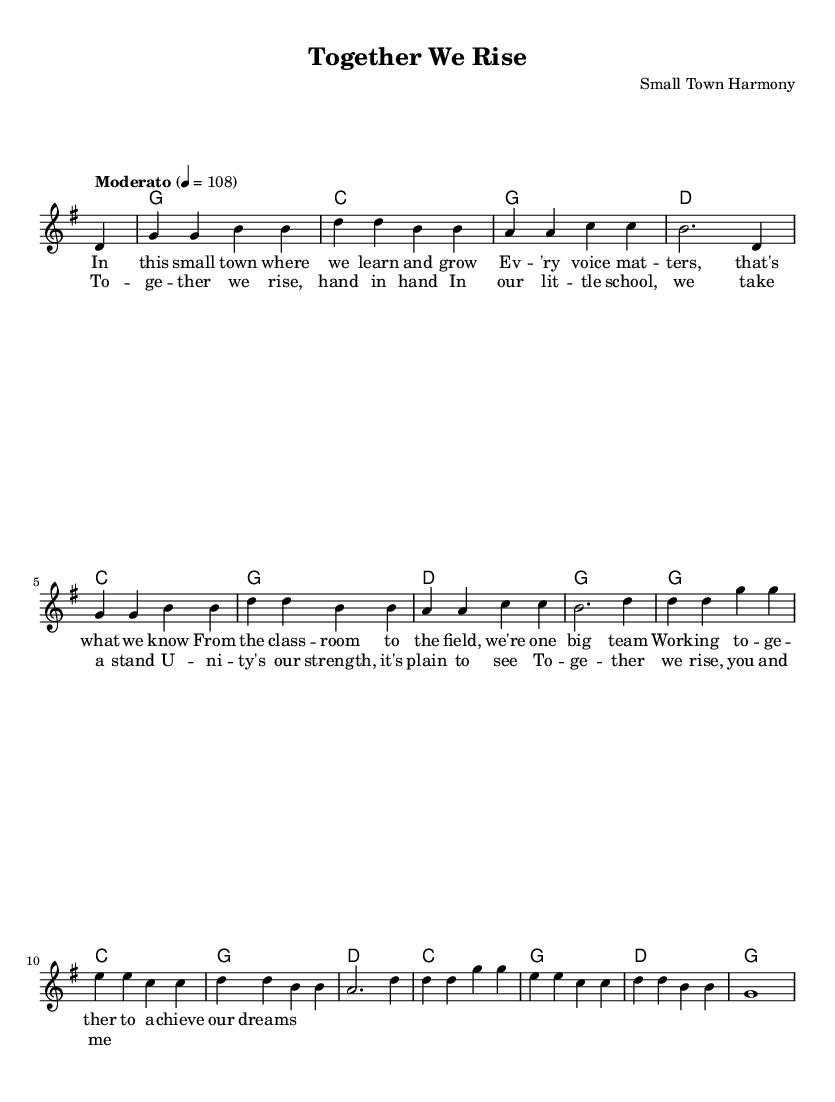What is the key signature of this music? The key signature is G major, which has one sharp (F#).
Answer: G major What is the time signature of this music? The time signature is 4/4, which means there are four beats in each measure and the quarter note gets one beat.
Answer: 4/4 What is the tempo indicated in the music? The tempo is marked as Moderato, with a metronome indication of 108 beats per minute.
Answer: 108 How many measures are in the melody section? The melody section consists of 16 measures, as indicated by the number of lines of music. Counting each measure, there are a total of 16.
Answer: 16 What is the first lyric line of the verse? The first lyric line of the verse is “In this small town where we learn and grow.” This is directly taken from the notation under the melody.
Answer: In this small town where we learn and grow What chord follows the second measure of the melody? The chord that follows the second measure (which is G) is another G chord, as shown in the harmonies notation.
Answer: G What is the theme of the song based on the lyrics? The theme of the song is about teamwork and unity in a small-town school context, as seen in both the verse and chorus lyrics.
Answer: Teamwork and unity 